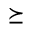<formula> <loc_0><loc_0><loc_500><loc_500>\succeq</formula> 